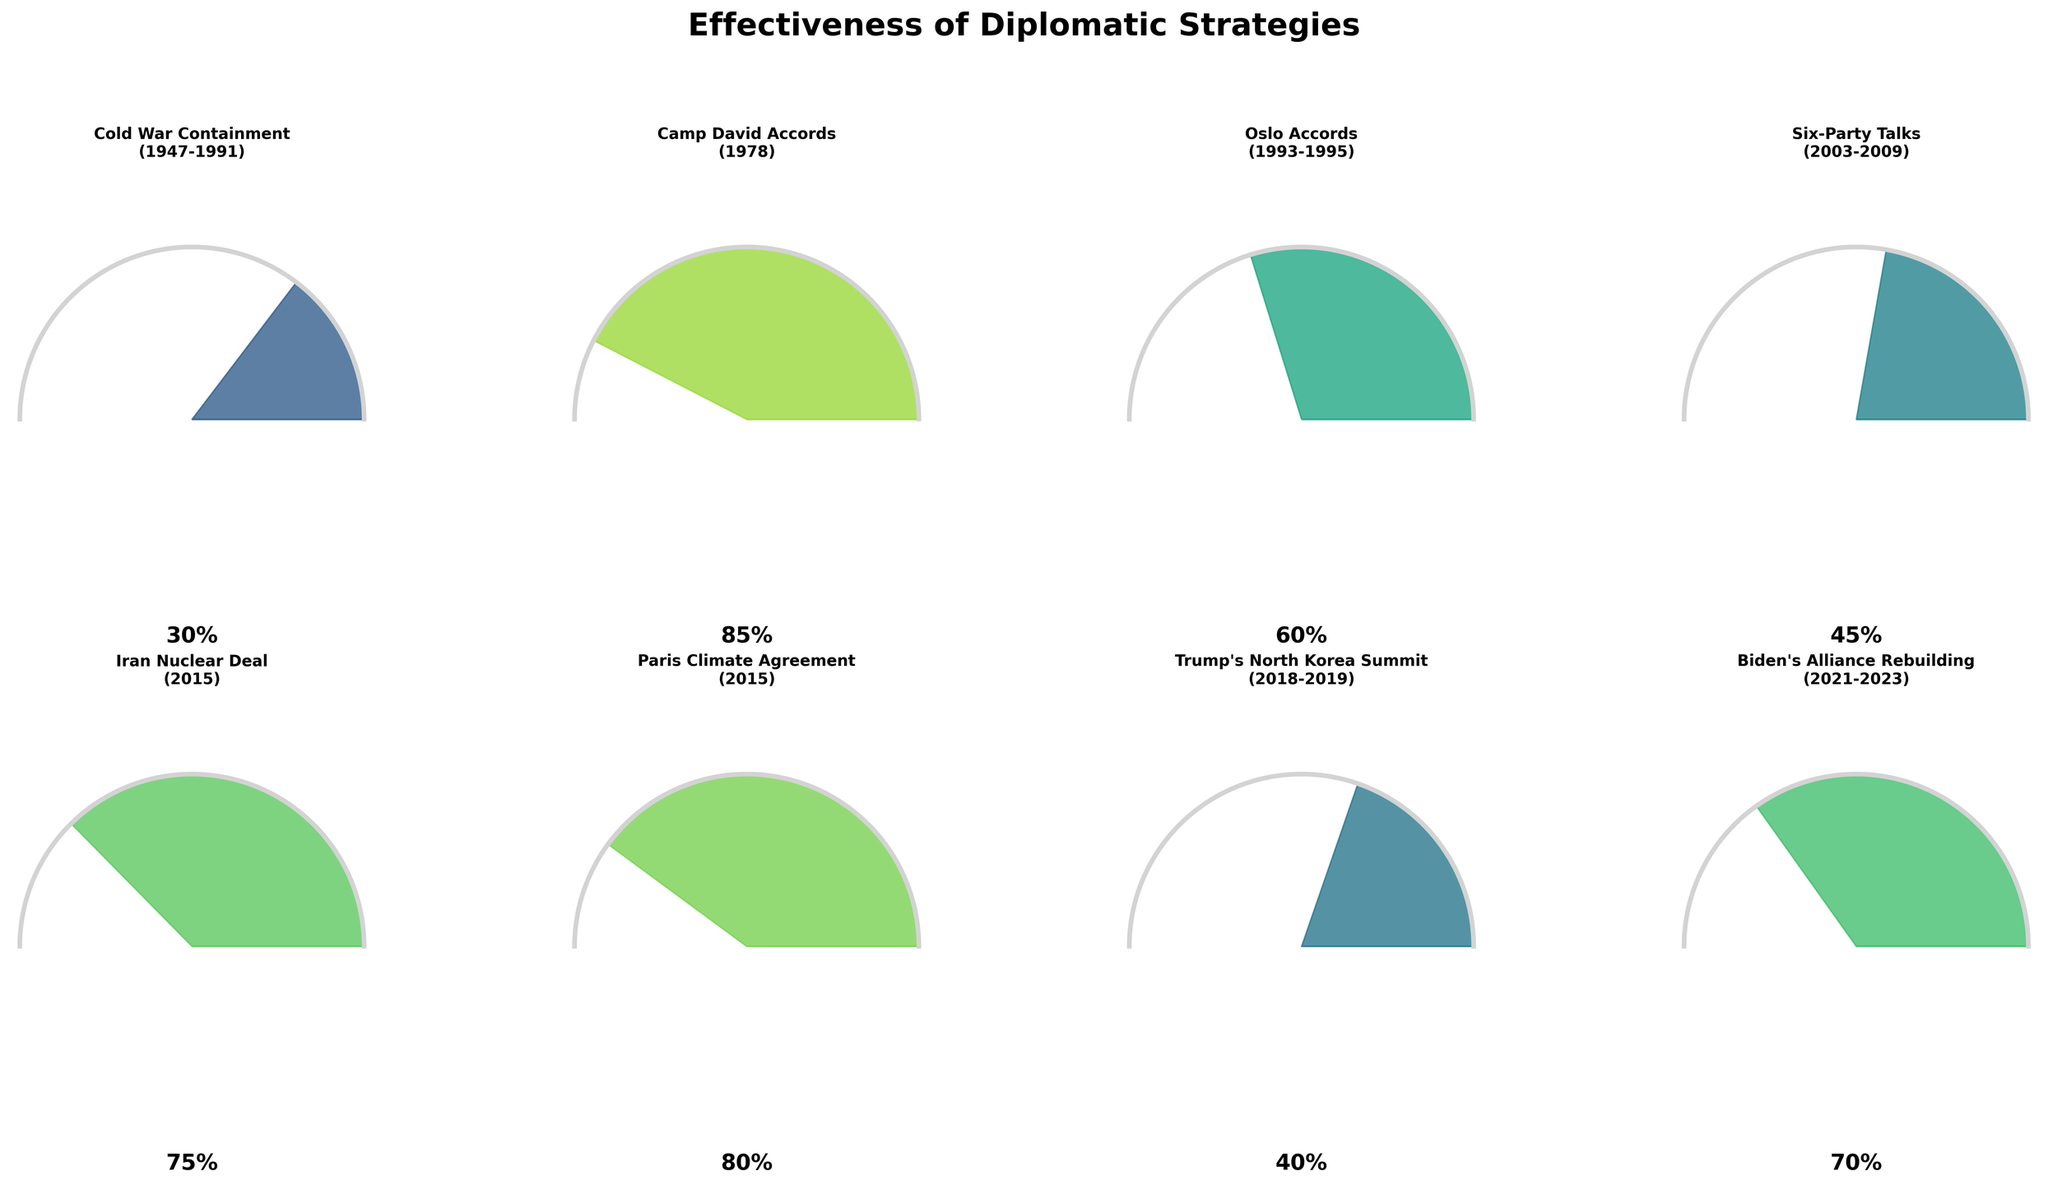What is the effectiveness score of the Camp David Accords? The gauge chart for the Camp David Accords shows an arrow pointing at 85%. This value is prominently displayed as part of the gauge plot for that strategy and era.
Answer: 85% Which diplomatic strategy has the highest effectiveness score? By comparing all gauge charts, the Camp David Accords has the highest effectiveness score with a value of 85%.
Answer: Camp David Accords How many diplomatic strategies have an effectiveness score less than 50%? Looking at the gauges, Cold War Containment (30%), Six-Party Talks (45%), and Trump’s North Korea Summit (40%) all have effectiveness scores below 50%. This totals to three strategies.
Answer: 3 Which diplomatic strategies from the 21st century have effectiveness scores above 70%? From the gauge charts, the Paris Climate Agreement (2015) with an 80% score and Biden’s Alliance Rebuilding (2021-2023) with a 70% score demonstrate strategies from the 21st century with effectiveness scores around or above 70%.
Answer: Paris Climate Agreement, Biden’s Alliance Rebuilding What is the difference in the effectiveness scores between the Oslo Accords and the Iran Nuclear Deal? The Oslo Accords have an effectiveness score of 60%, whereas the Iran Nuclear Deal has a score of 75%. The difference is calculated as 75 - 60 = 15%.
Answer: 15% How does the effectiveness of Biden’s Alliance Rebuilding compare to the Trump’s North Korea Summit? Biden’s Alliance Rebuilding has a score of 70%, and the Trump’s North Korea Summit has a score of 40%. Therefore, Biden’s strategy is more effective by a margin of 30%.
Answer: Biden’s strategy is 30% more effective What is the average effectiveness score of all the strategies displayed? Summing up all effectiveness scores (30 + 85 + 60 + 45 + 75 + 80 + 40 + 70) gives 485. There are 8 strategies, so the average effectiveness score is 485/8 = 60.625%.
Answer: 60.625% Which eras involve multiple diplomatic strategies, and what are their effectiveness scores? The 2015 era has two strategies: the Iran Nuclear Deal (75%) and the Paris Climate Agreement (80%).
Answer: 2015: Iran Nuclear Deal (75%), Paris Climate Agreement (80%) What would you infer about the trend in the effectiveness of diplomatic strategies over time? Observing the gauge charts, early strategies like Cold War Containment (30%) have lower effectiveness compared to more recent strategies such as the Paris Climate Agreement (80%) and Biden’s Alliance Rebuilding (70%). This suggests an improvement in the effectiveness of diplomatic strategies over time.
Answer: Improvement over time 